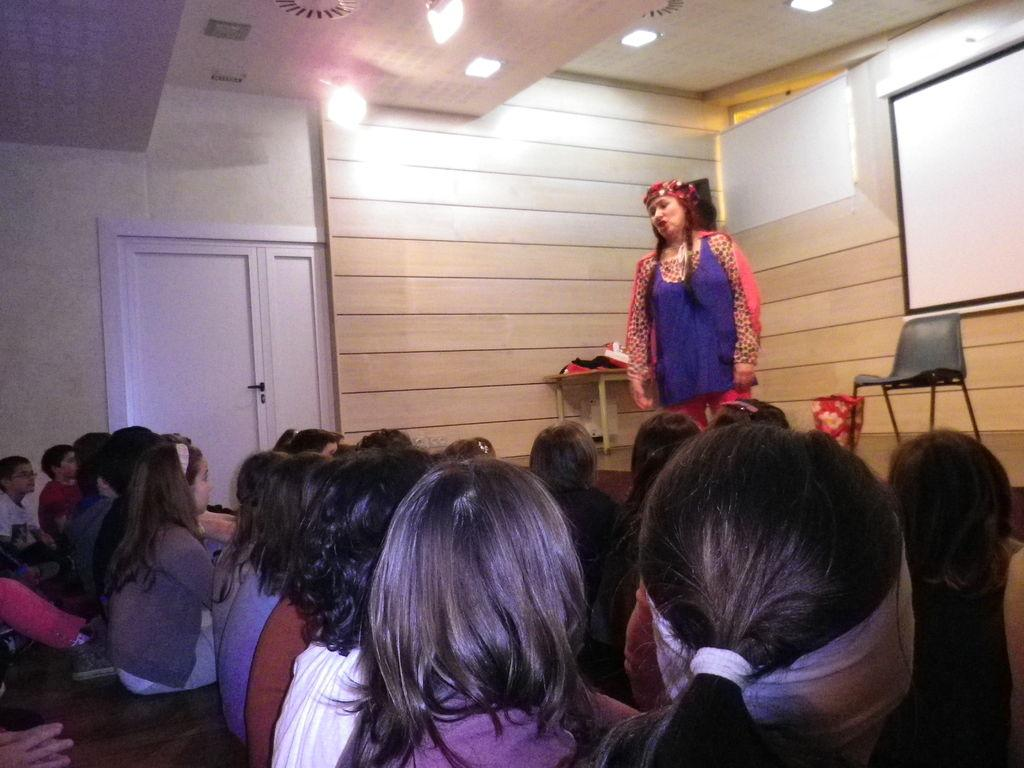What are the people in the image doing? There is a group of people sitting in the image. Is there anyone standing in the image? Yes, there is a person standing in the image. What type of furniture is present in the image? There are chairs and a table in the image. What can be seen on the wall in the image? There is a screen in the image. What architectural feature is present in the image? There is a door in the image. What type of lighting is present in the image? There are lights in the image. What type of treatment is being administered to the person standing in the image? There is no indication of any treatment being administered in the image; the person is simply standing. How many rings are visible on the table in the image? There are no rings visible on the table in the image. 